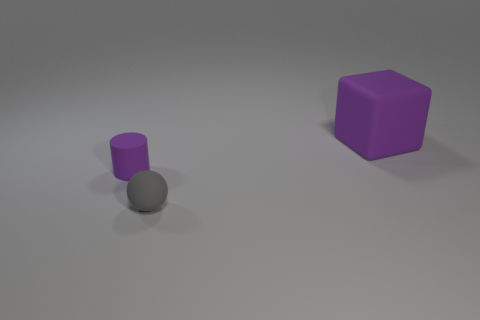Add 2 purple metal cylinders. How many objects exist? 5 Subtract all cylinders. How many objects are left? 2 Subtract all purple rubber blocks. Subtract all large spheres. How many objects are left? 2 Add 2 purple objects. How many purple objects are left? 4 Add 1 small matte balls. How many small matte balls exist? 2 Subtract 0 brown blocks. How many objects are left? 3 